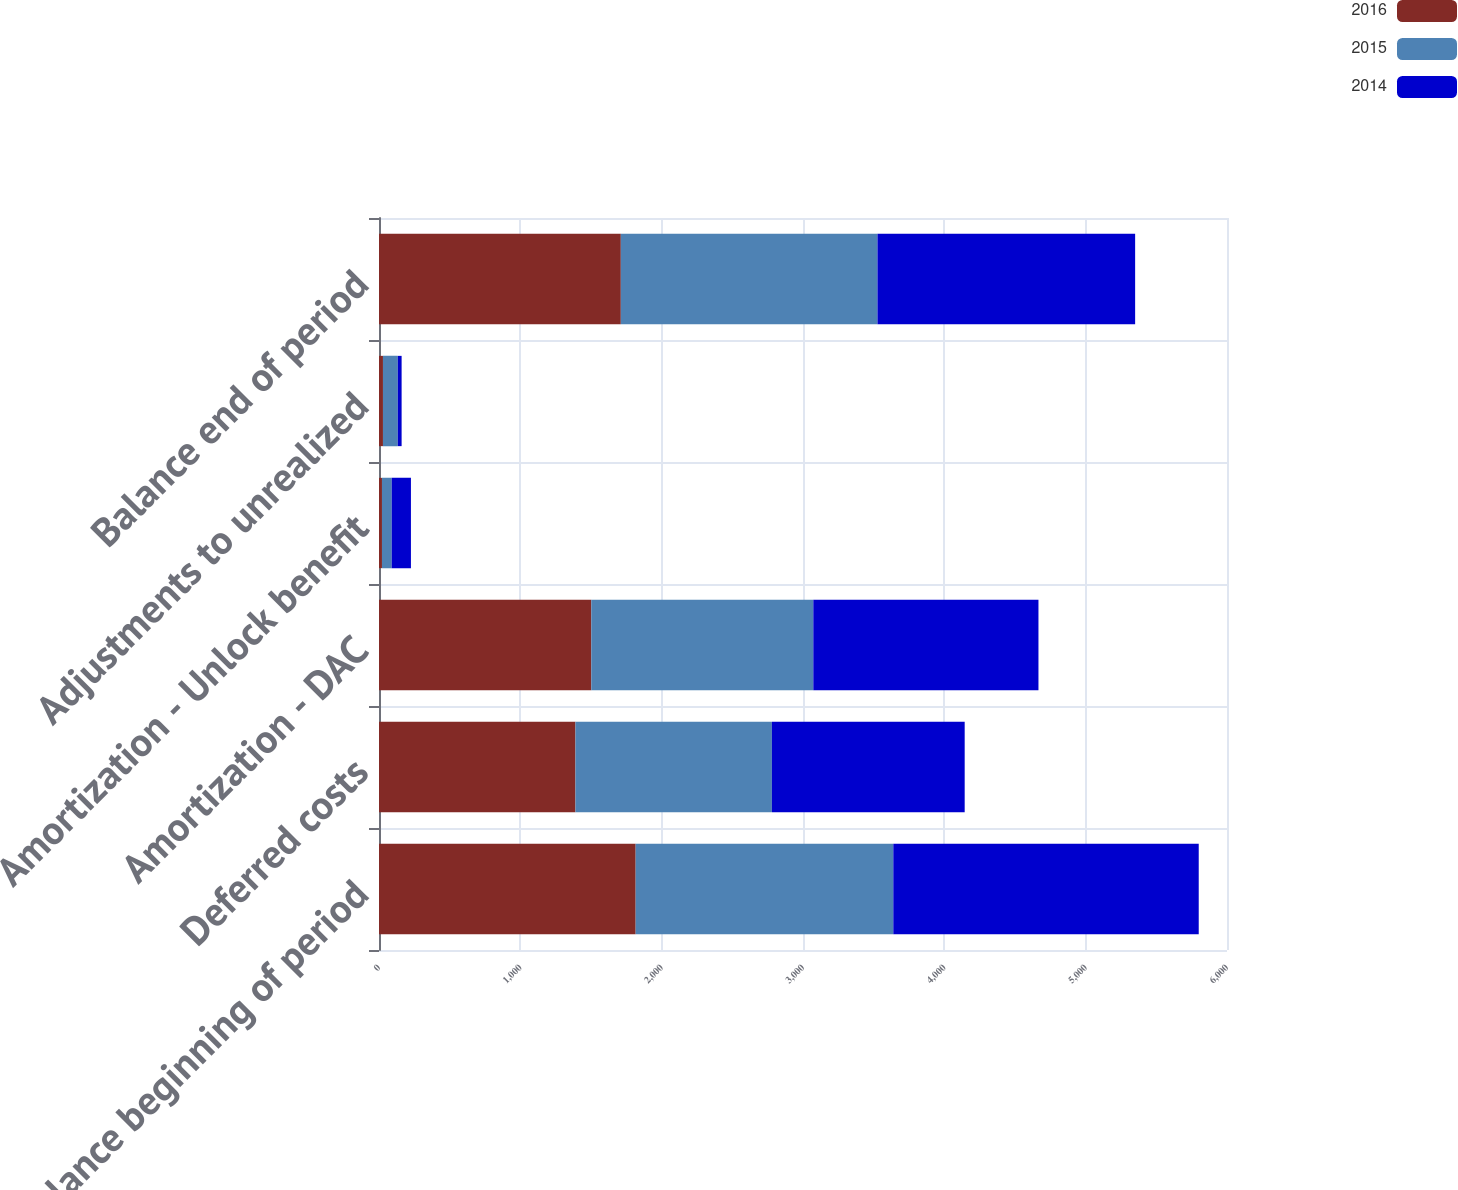Convert chart. <chart><loc_0><loc_0><loc_500><loc_500><stacked_bar_chart><ecel><fcel>Balance beginning of period<fcel>Deferred costs<fcel>Amortization - DAC<fcel>Amortization - Unlock benefit<fcel>Adjustments to unrealized<fcel>Balance end of period<nl><fcel>2016<fcel>1816<fcel>1390<fcel>1502<fcel>21<fcel>28<fcel>1711<nl><fcel>2015<fcel>1823<fcel>1390<fcel>1571<fcel>69<fcel>105<fcel>1816<nl><fcel>2014<fcel>2161<fcel>1364<fcel>1593<fcel>136<fcel>27<fcel>1823<nl></chart> 